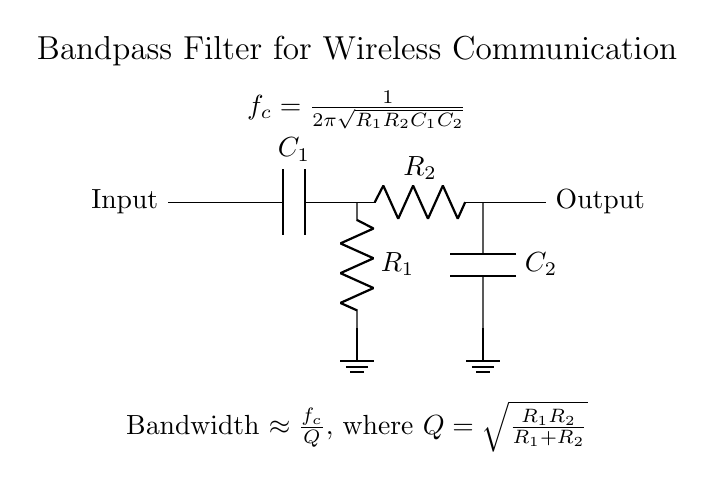What are the components in this bandpass filter? The components are two resistors and two capacitors, namely R1, R2, C1, and C2. These are explicitly labeled in the circuit diagram.
Answer: Resistors and capacitors What does the symbol with two parallel lines represent? The parallel lines represent a capacitor in the circuit, which stores electrical energy temporarily. The labels C1 and C2 denote the two capacitors in the circuit.
Answer: Capacitor What is the cutoff frequency for this circuit? The cutoff frequency \( f_c \) is given by the formula included in the circuit diagram, specifically \( f_c = \frac{1}{2\pi\sqrt{R_1R_2C_1C_2}} \). It defines the frequency range the filter allows to pass through.
Answer: Defined by the formula What happens to signals outside the bandwidth? Signals outside the specified bandwidth will be attenuated, meaning they are significantly reduced in amplitude because the filter primarily allows certain frequencies to pass while blocking others.
Answer: Attenuated How is the bandwidth calculated? The bandwidth is calculated using the formula provided in the diagram, where Bandwidth \( \approx \frac{f_c}{Q} \) and \( Q = \sqrt{\frac{R_1R_2}{R_1+R_2}} \). This involves understanding both the cutoff frequency and the quality factor.
Answer: \( \frac{f_c}{Q} \) What characteristic of the filter does the quality factor Q represent? The quality factor Q characterizes the selectivity or sharpness of the filter’s response at its center frequency. A higher Q indicates a narrower bandwidth and better selectivity. It is computed using the resistances in the circuit.
Answer: Selectivity or sharpness 